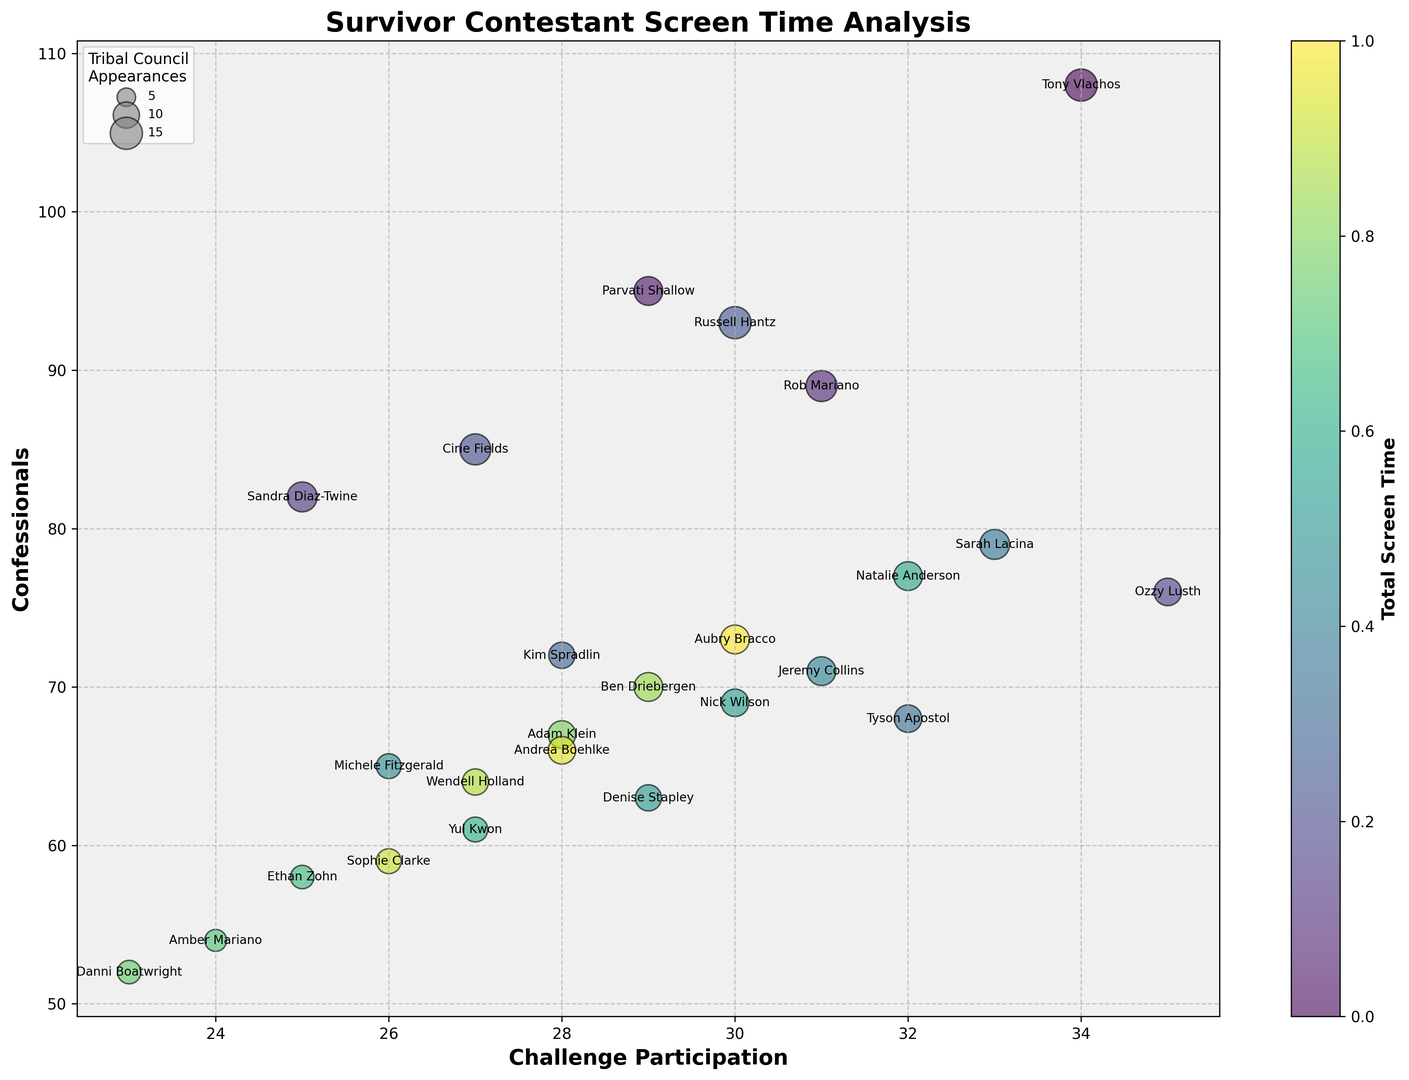Which contestant had the highest number of confessionals and how many did they have? Look around the y-axis to find the contestant with the highest value. Tony Vlachos has the most confessionals, with a y-value of 108
Answer: Tony Vlachos, 108 Which contestant participated in the most challenges? Look at the x-axis to find the contestant with the highest challenge participation value. Ozzy Lusth has the highest x-value of 35
Answer: Ozzy Lusth Who had the most appearances in tribal councils? Examine the size of the bubbles (larger bubbles indicate more appearances). Tony Vlachos and Russell Hantz both have the largest bubble size, which corresponds to 15 appearances
Answer: Tony Vlachos and Russell Hantz, 15 Which contestant had the least screen time and how much was it? Look at the color bar to identify the lightest shade, which represents the contestant with the least screen time. Danni Boatwright, represented by the lightest shade, has 83 units of screen time
Answer: Danni Boatwright, 83 Which contestants have at least 30 challenge participations and more than 70 confessionals? Filter through the data points where x-values are at least 30 and y-values are greater than 70. Tony Vlachos, Parvati Shallow, Rob Mariano, Russell Hantz, and Sarah Lacina meet this criteria
Answer: Tony Vlachos, Parvati Shallow, Rob Mariano, Russell Hantz, Sarah Lacina What is the sum of the confessionals of contestants with exactly 30 tribal council appearances? Identify the contestants with a bubble size (z-value) of 30: Russell Hantz, Jeremy Collins, and Aubry Bracco. Sum their y-values: 93 (Russell) + 71 (Jeremy) + 73 (Aubry) = 237
Answer: 237 Which contestant has the closest screen time to Kim Spradlin and how is their challenge participation different? Kim Spradlin has 110 screen time units, indicated by her color. Ethan Zohn and Wendell Holland (both with 111 screen time) are closest. Compare challenge participations: 32 (Tyson) - 28 (Kim) = 4
Answer: Wendell Holland, 4 Who appears to have the highest challenge participation but less than 70 confessionals? Look for the highest x-value (challenge participation) with a y-value (confessionals) below 70. Tyson Apostol (with 32 challenge participations and 68 confessionals) meets this criterion
Answer: Tyson Apostol 